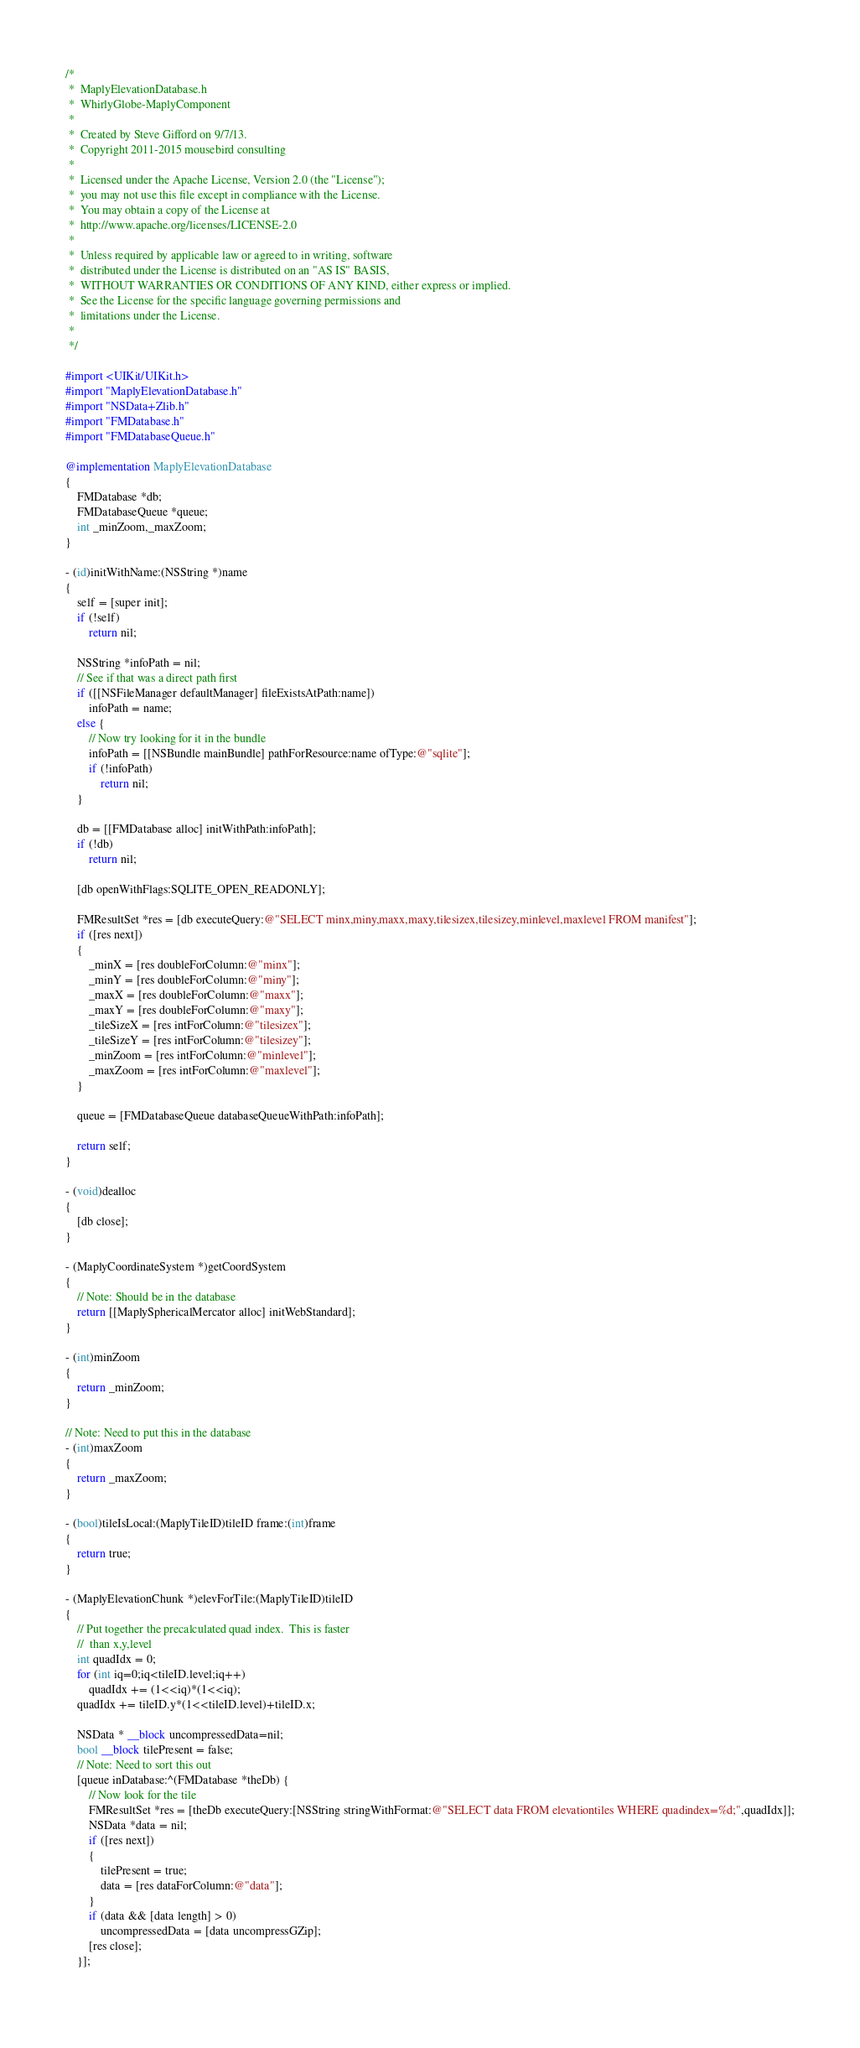Convert code to text. <code><loc_0><loc_0><loc_500><loc_500><_ObjectiveC_>/*
 *  MaplyElevationDatabase.h
 *  WhirlyGlobe-MaplyComponent
 *
 *  Created by Steve Gifford on 9/7/13.
 *  Copyright 2011-2015 mousebird consulting
 *
 *  Licensed under the Apache License, Version 2.0 (the "License");
 *  you may not use this file except in compliance with the License.
 *  You may obtain a copy of the License at
 *  http://www.apache.org/licenses/LICENSE-2.0
 *
 *  Unless required by applicable law or agreed to in writing, software
 *  distributed under the License is distributed on an "AS IS" BASIS,
 *  WITHOUT WARRANTIES OR CONDITIONS OF ANY KIND, either express or implied.
 *  See the License for the specific language governing permissions and
 *  limitations under the License.
 *
 */

#import <UIKit/UIKit.h>
#import "MaplyElevationDatabase.h"
#import "NSData+Zlib.h"
#import "FMDatabase.h"
#import "FMDatabaseQueue.h"

@implementation MaplyElevationDatabase
{
    FMDatabase *db;
    FMDatabaseQueue *queue;
    int _minZoom,_maxZoom;
}

- (id)initWithName:(NSString *)name
{
    self = [super init];
    if (!self)
        return nil;
    
    NSString *infoPath = nil;
    // See if that was a direct path first
    if ([[NSFileManager defaultManager] fileExistsAtPath:name])
        infoPath = name;
    else {
        // Now try looking for it in the bundle
        infoPath = [[NSBundle mainBundle] pathForResource:name ofType:@"sqlite"];
        if (!infoPath)
            return nil;
    }
    
    db = [[FMDatabase alloc] initWithPath:infoPath];
    if (!db)
        return nil;
    
    [db openWithFlags:SQLITE_OPEN_READONLY];
    
    FMResultSet *res = [db executeQuery:@"SELECT minx,miny,maxx,maxy,tilesizex,tilesizey,minlevel,maxlevel FROM manifest"];
    if ([res next])
    {
        _minX = [res doubleForColumn:@"minx"];
        _minY = [res doubleForColumn:@"miny"];
        _maxX = [res doubleForColumn:@"maxx"];
        _maxY = [res doubleForColumn:@"maxy"];
        _tileSizeX = [res intForColumn:@"tilesizex"];
        _tileSizeY = [res intForColumn:@"tilesizey"];
        _minZoom = [res intForColumn:@"minlevel"];
        _maxZoom = [res intForColumn:@"maxlevel"];
    }
    
    queue = [FMDatabaseQueue databaseQueueWithPath:infoPath];

    return self;
}

- (void)dealloc
{
    [db close];
}

- (MaplyCoordinateSystem *)getCoordSystem
{
    // Note: Should be in the database
    return [[MaplySphericalMercator alloc] initWebStandard];
}

- (int)minZoom
{
    return _minZoom;
}

// Note: Need to put this in the database
- (int)maxZoom
{
    return _maxZoom;
}

- (bool)tileIsLocal:(MaplyTileID)tileID frame:(int)frame
{
    return true;
}

- (MaplyElevationChunk *)elevForTile:(MaplyTileID)tileID
{
    // Put together the precalculated quad index.  This is faster
    //  than x,y,level
    int quadIdx = 0;
    for (int iq=0;iq<tileID.level;iq++)
        quadIdx += (1<<iq)*(1<<iq);
    quadIdx += tileID.y*(1<<tileID.level)+tileID.x;

    NSData * __block uncompressedData=nil;
    bool __block tilePresent = false;
    // Note: Need to sort this out
    [queue inDatabase:^(FMDatabase *theDb) {
        // Now look for the tile
        FMResultSet *res = [theDb executeQuery:[NSString stringWithFormat:@"SELECT data FROM elevationtiles WHERE quadindex=%d;",quadIdx]];
        NSData *data = nil;
        if ([res next])
        {
            tilePresent = true;
            data = [res dataForColumn:@"data"];
        }
        if (data && [data length] > 0)
            uncompressedData = [data uncompressGZip];
        [res close];
    }];
    </code> 